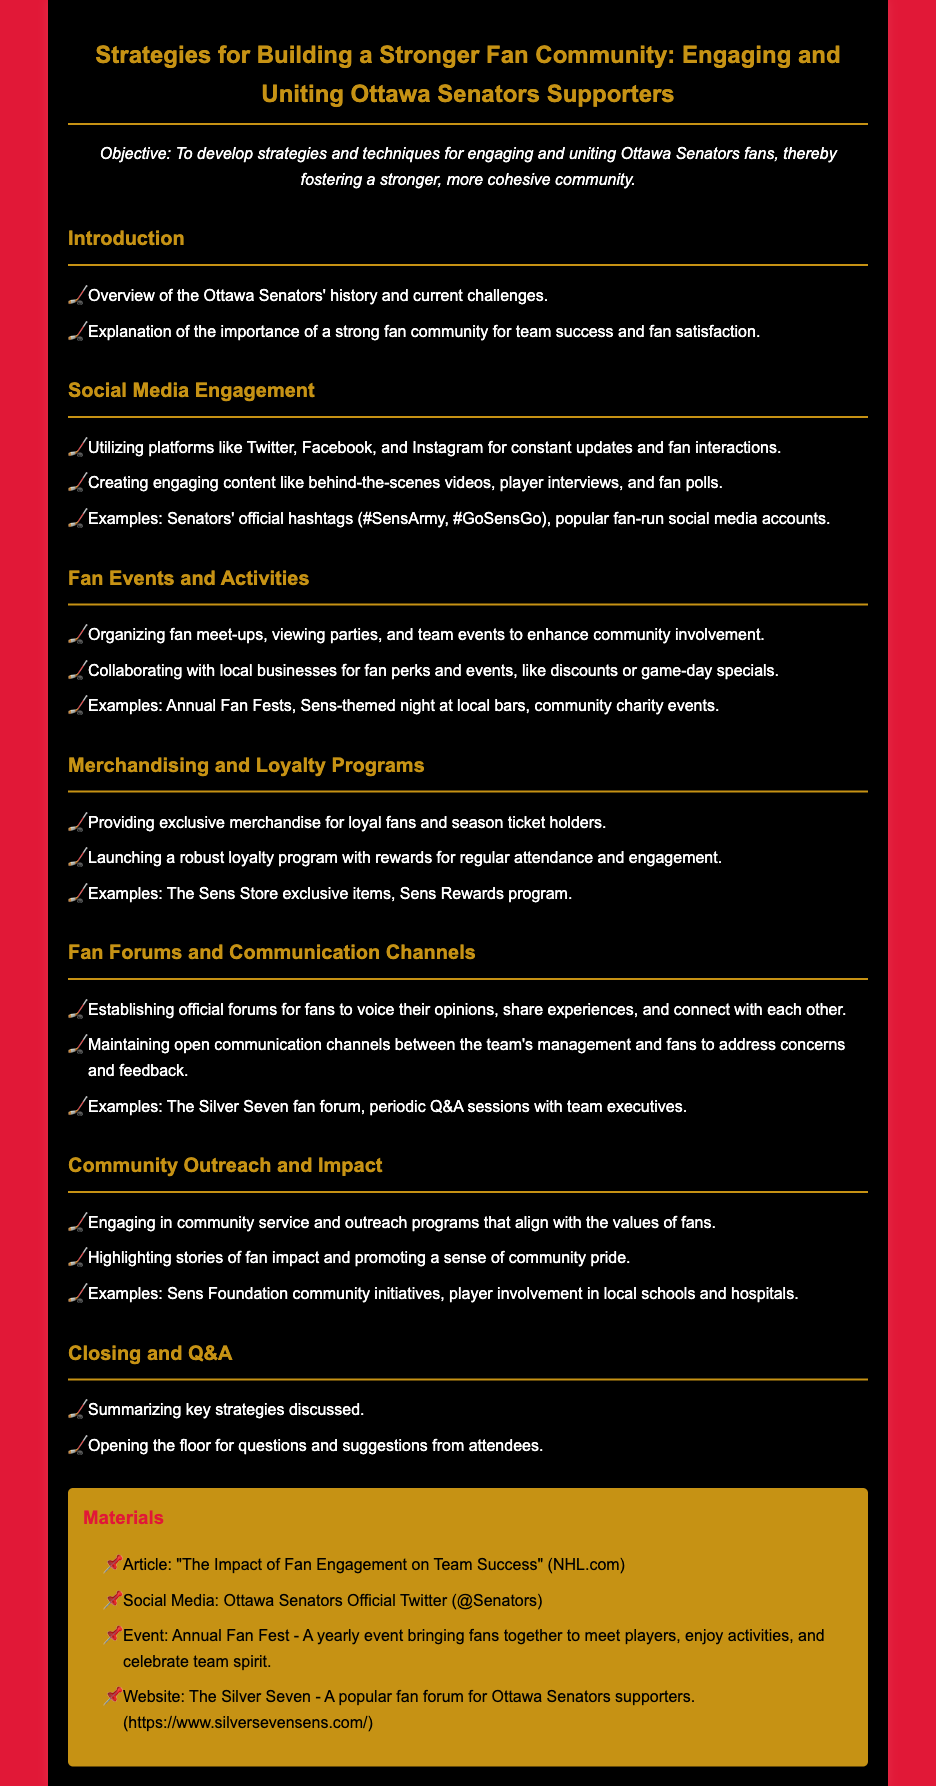What is the objective of the lesson plan? The objective is stated at the beginning of the document, which focuses on developing strategies and techniques for fan engagement.
Answer: To develop strategies and techniques for engaging and uniting Ottawa Senators fans, thereby fostering a stronger, more cohesive community Which social media platforms are mentioned for fan engagement? The document specifically lists platforms that can be utilized for constant updates and fan interactions.
Answer: Twitter, Facebook, and Instagram What are fan meet-ups classified as? The document categorizes fan meet-ups and viewing parties under fan events and activities to enhance community involvement.
Answer: Fan events and activities What type of merchandise is provided to loyal fans? The section on merchandising specifies that exclusive merchandise is offered to loyal fans and season ticket holders.
Answer: Exclusive merchandise What initiative highlights the community impact of fans? The document gives examples of initiatives that showcase fan impact and promote community pride.
Answer: Sens Foundation community initiatives Which fan forum is mentioned in the document? The document specifies a popular fan forum for Ottawa Senators supporters.
Answer: The Silver Seven What is an example of a fan event organized by the Senators? The document lists specific events organized to bring fans together and enhance community involvement.
Answer: Annual Fan Fest How does the document describe communication with fans? It mentions maintaining open channels for communication between the team's management and the fans.
Answer: Open communication channels 